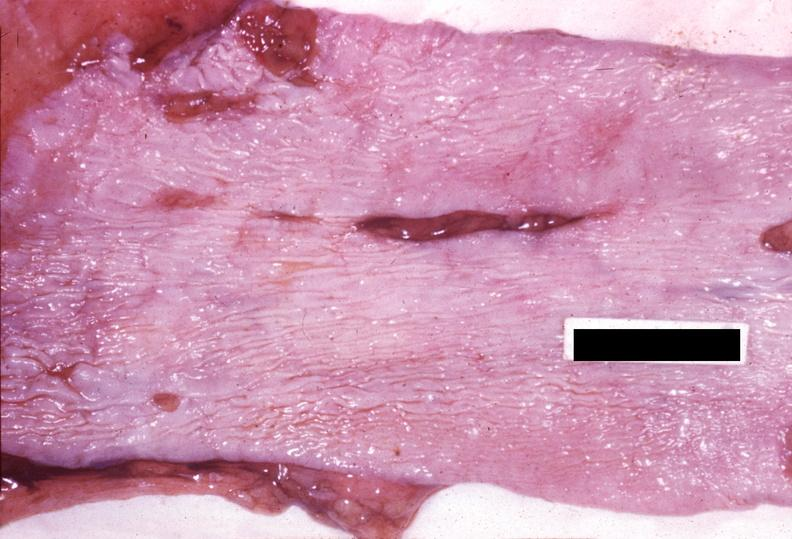what does this image show?
Answer the question using a single word or phrase. Esophagus 